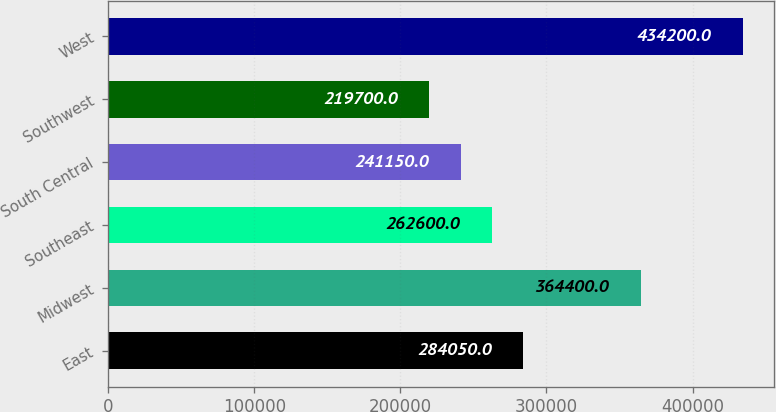Convert chart to OTSL. <chart><loc_0><loc_0><loc_500><loc_500><bar_chart><fcel>East<fcel>Midwest<fcel>Southeast<fcel>South Central<fcel>Southwest<fcel>West<nl><fcel>284050<fcel>364400<fcel>262600<fcel>241150<fcel>219700<fcel>434200<nl></chart> 